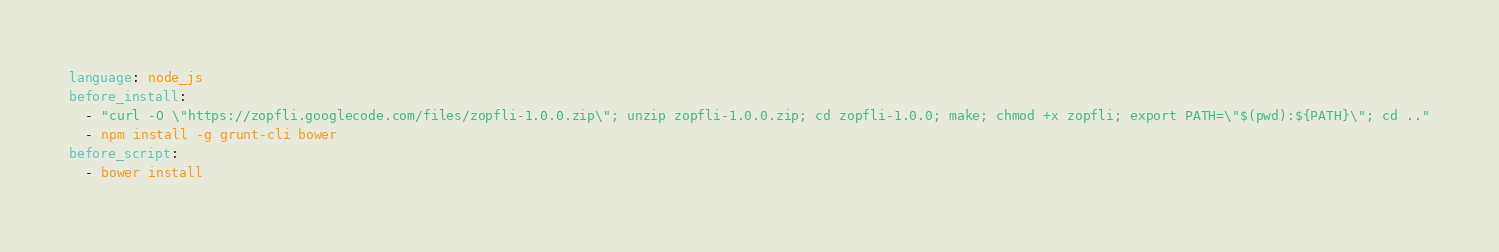<code> <loc_0><loc_0><loc_500><loc_500><_YAML_>language: node_js
before_install:
  - "curl -O \"https://zopfli.googlecode.com/files/zopfli-1.0.0.zip\"; unzip zopfli-1.0.0.zip; cd zopfli-1.0.0; make; chmod +x zopfli; export PATH=\"$(pwd):${PATH}\"; cd .."
  - npm install -g grunt-cli bower
before_script:
  - bower install
</code> 